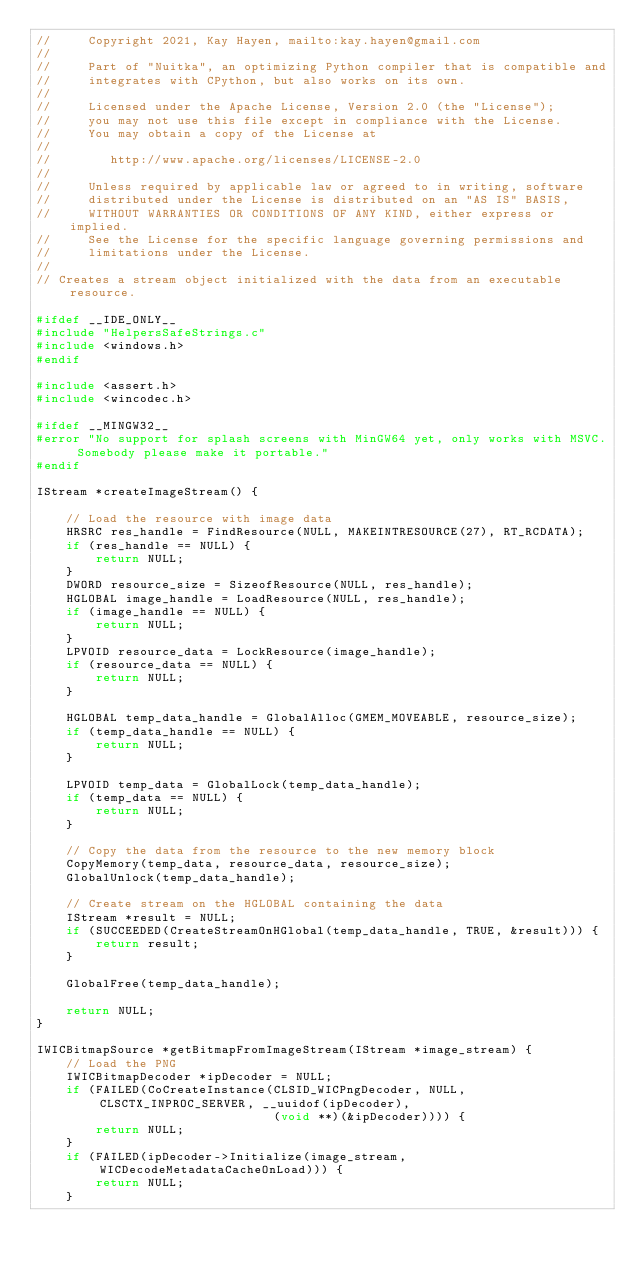Convert code to text. <code><loc_0><loc_0><loc_500><loc_500><_C++_>//     Copyright 2021, Kay Hayen, mailto:kay.hayen@gmail.com
//
//     Part of "Nuitka", an optimizing Python compiler that is compatible and
//     integrates with CPython, but also works on its own.
//
//     Licensed under the Apache License, Version 2.0 (the "License");
//     you may not use this file except in compliance with the License.
//     You may obtain a copy of the License at
//
//        http://www.apache.org/licenses/LICENSE-2.0
//
//     Unless required by applicable law or agreed to in writing, software
//     distributed under the License is distributed on an "AS IS" BASIS,
//     WITHOUT WARRANTIES OR CONDITIONS OF ANY KIND, either express or implied.
//     See the License for the specific language governing permissions and
//     limitations under the License.
//
// Creates a stream object initialized with the data from an executable resource.

#ifdef __IDE_ONLY__
#include "HelpersSafeStrings.c"
#include <windows.h>
#endif

#include <assert.h>
#include <wincodec.h>

#ifdef __MINGW32__
#error "No support for splash screens with MinGW64 yet, only works with MSVC. Somebody please make it portable."
#endif

IStream *createImageStream() {

    // Load the resource with image data
    HRSRC res_handle = FindResource(NULL, MAKEINTRESOURCE(27), RT_RCDATA);
    if (res_handle == NULL) {
        return NULL;
    }
    DWORD resource_size = SizeofResource(NULL, res_handle);
    HGLOBAL image_handle = LoadResource(NULL, res_handle);
    if (image_handle == NULL) {
        return NULL;
    }
    LPVOID resource_data = LockResource(image_handle);
    if (resource_data == NULL) {
        return NULL;
    }

    HGLOBAL temp_data_handle = GlobalAlloc(GMEM_MOVEABLE, resource_size);
    if (temp_data_handle == NULL) {
        return NULL;
    }

    LPVOID temp_data = GlobalLock(temp_data_handle);
    if (temp_data == NULL) {
        return NULL;
    }

    // Copy the data from the resource to the new memory block
    CopyMemory(temp_data, resource_data, resource_size);
    GlobalUnlock(temp_data_handle);

    // Create stream on the HGLOBAL containing the data
    IStream *result = NULL;
    if (SUCCEEDED(CreateStreamOnHGlobal(temp_data_handle, TRUE, &result))) {
        return result;
    }

    GlobalFree(temp_data_handle);

    return NULL;
}

IWICBitmapSource *getBitmapFromImageStream(IStream *image_stream) {
    // Load the PNG
    IWICBitmapDecoder *ipDecoder = NULL;
    if (FAILED(CoCreateInstance(CLSID_WICPngDecoder, NULL, CLSCTX_INPROC_SERVER, __uuidof(ipDecoder),
                                (void **)(&ipDecoder)))) {
        return NULL;
    }
    if (FAILED(ipDecoder->Initialize(image_stream, WICDecodeMetadataCacheOnLoad))) {
        return NULL;
    }</code> 